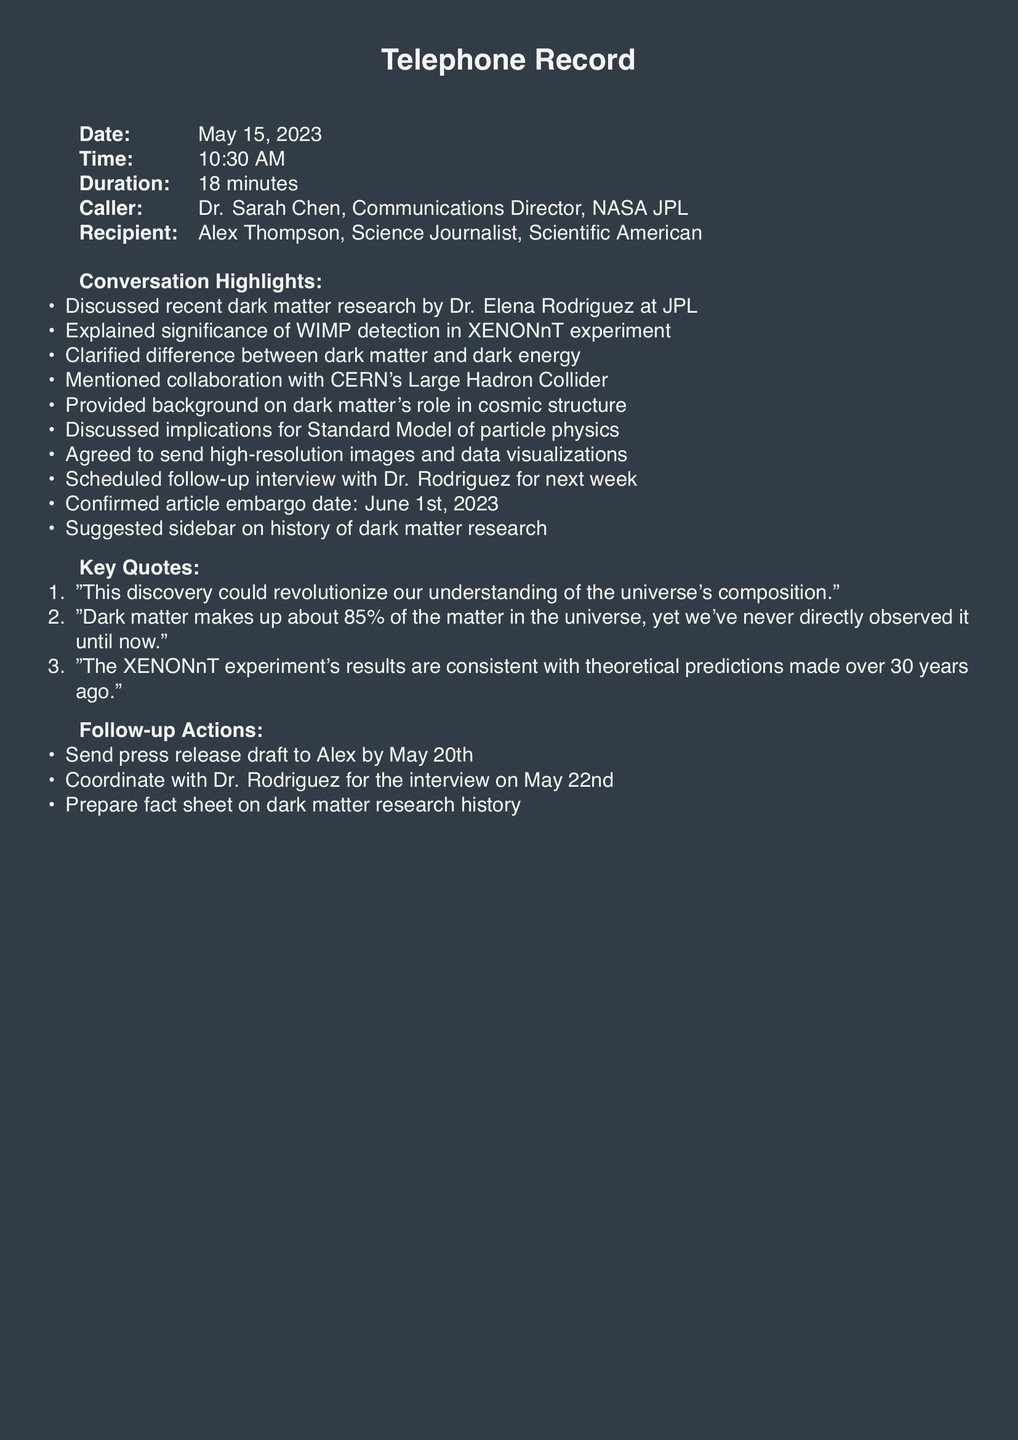What is the date of the call? The date of the call is specified in the document as May 15, 2023.
Answer: May 15, 2023 Who is the caller? The caller is identified in the document as Dr. Sarah Chen, Communications Director, NASA JPL.
Answer: Dr. Sarah Chen What experiment is mentioned in the conversation? The conversation discusses the XENONnT experiment related to dark matter research.
Answer: XENONnT What is the article embargo date? The document states that the article embargo date is June 1st, 2023.
Answer: June 1st, 2023 What percentage of the universe does dark matter make up? According to the document, dark matter makes up about 85% of the universe's matter.
Answer: 85% What is the follow-up interview scheduled for? The follow-up interview is specifically scheduled with Dr. Rodriguez for May 22nd.
Answer: May 22nd Which collaboration is mentioned in the highlights? The highlights reference a collaboration with CERN's Large Hadron Collider.
Answer: CERN's Large Hadron Collider What is one key quote from the conversation? The document includes several key quotes; one specific quote is about the discovery revolutionizing understanding of the universe.
Answer: "This discovery could revolutionize our understanding of the universe's composition." 